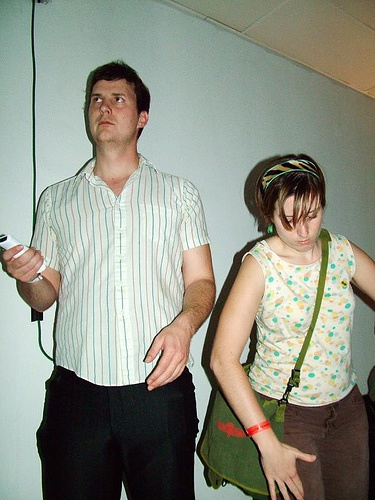Describe the objects in this image and their specific colors. I can see people in teal, black, ivory, darkgray, and gray tones, people in teal, beige, black, and tan tones, handbag in teal, darkgreen, black, and tan tones, and remote in teal, lightgray, darkgray, and black tones in this image. 